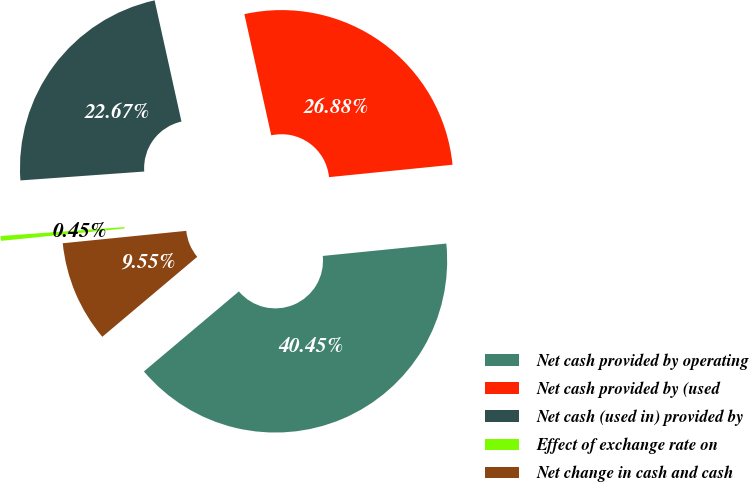Convert chart. <chart><loc_0><loc_0><loc_500><loc_500><pie_chart><fcel>Net cash provided by operating<fcel>Net cash provided by (used<fcel>Net cash (used in) provided by<fcel>Effect of exchange rate on<fcel>Net change in cash and cash<nl><fcel>40.45%<fcel>26.88%<fcel>22.67%<fcel>0.45%<fcel>9.55%<nl></chart> 